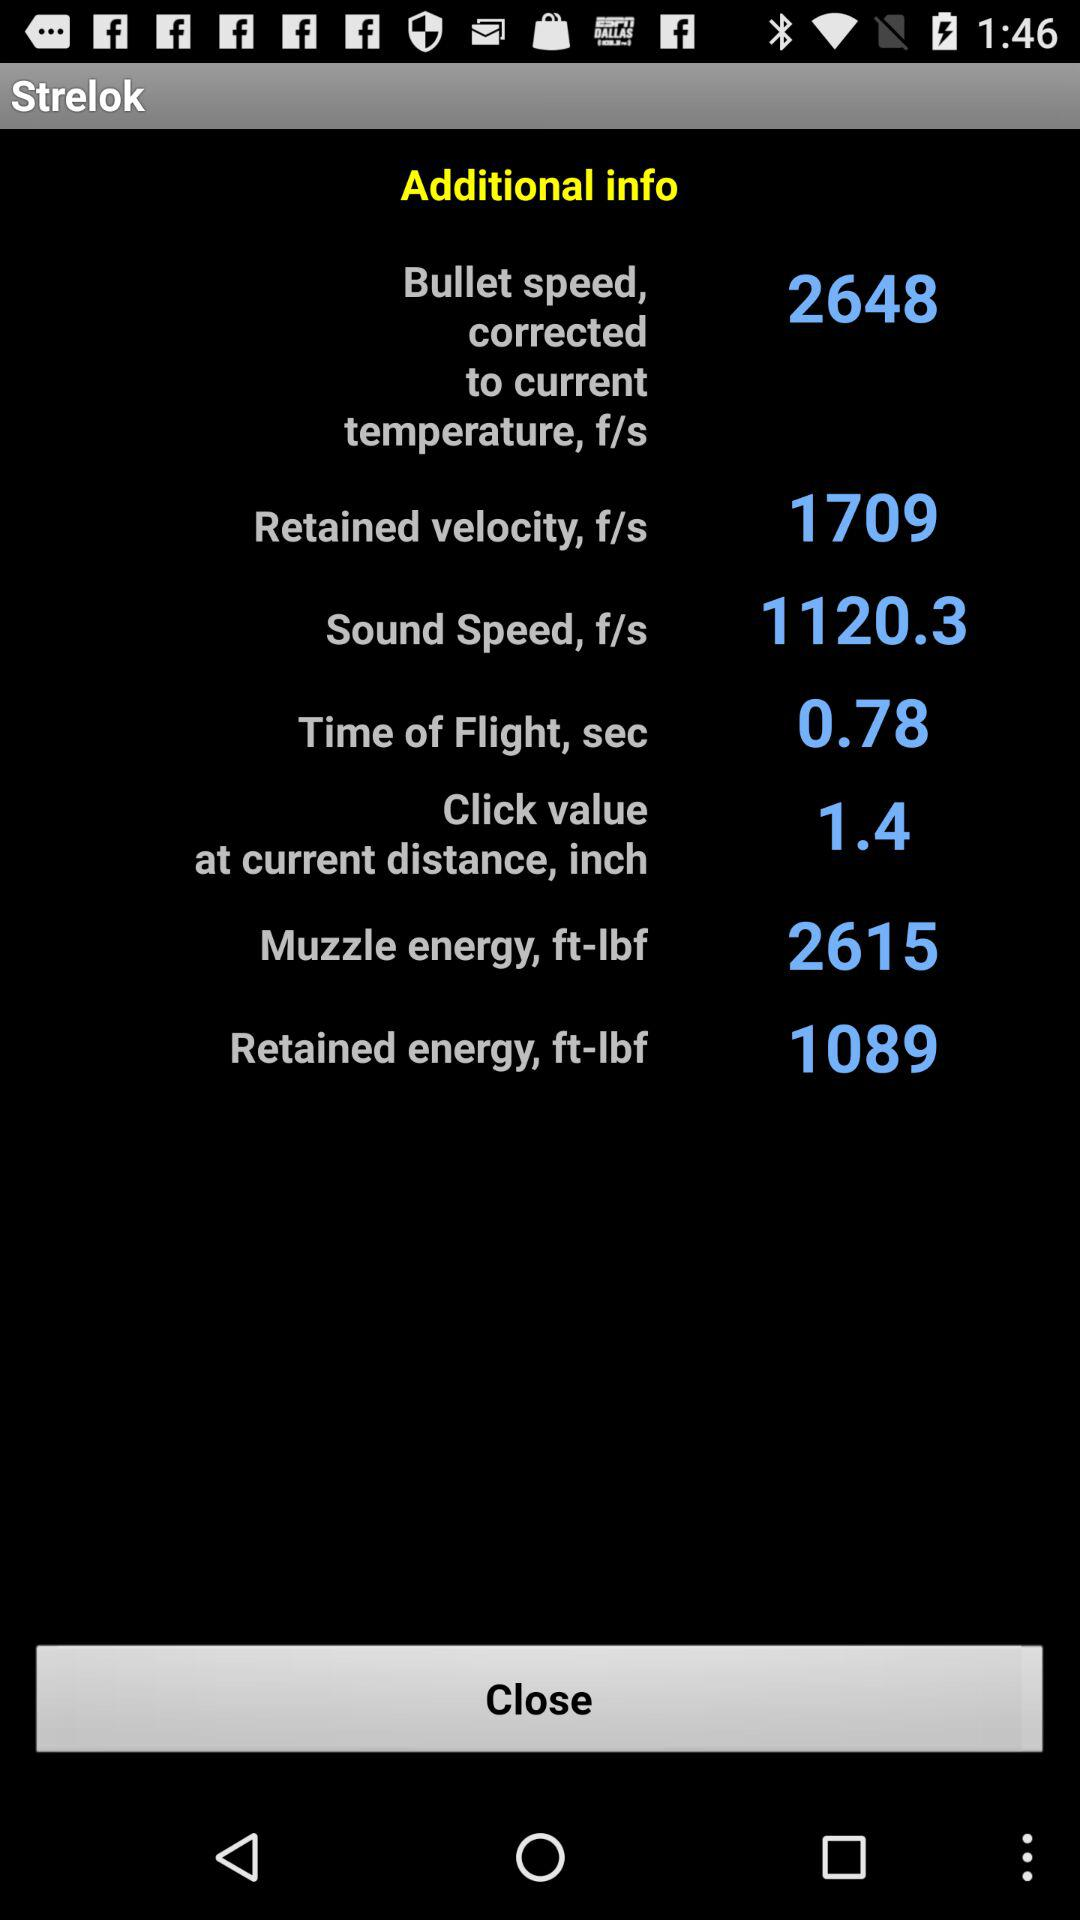What is the retained velocity of the bullet? The retained velocity of the bullet is 1709 f/s. 